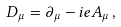<formula> <loc_0><loc_0><loc_500><loc_500>D _ { \mu } = \partial _ { \mu } - i e A _ { \mu } \, ,</formula> 